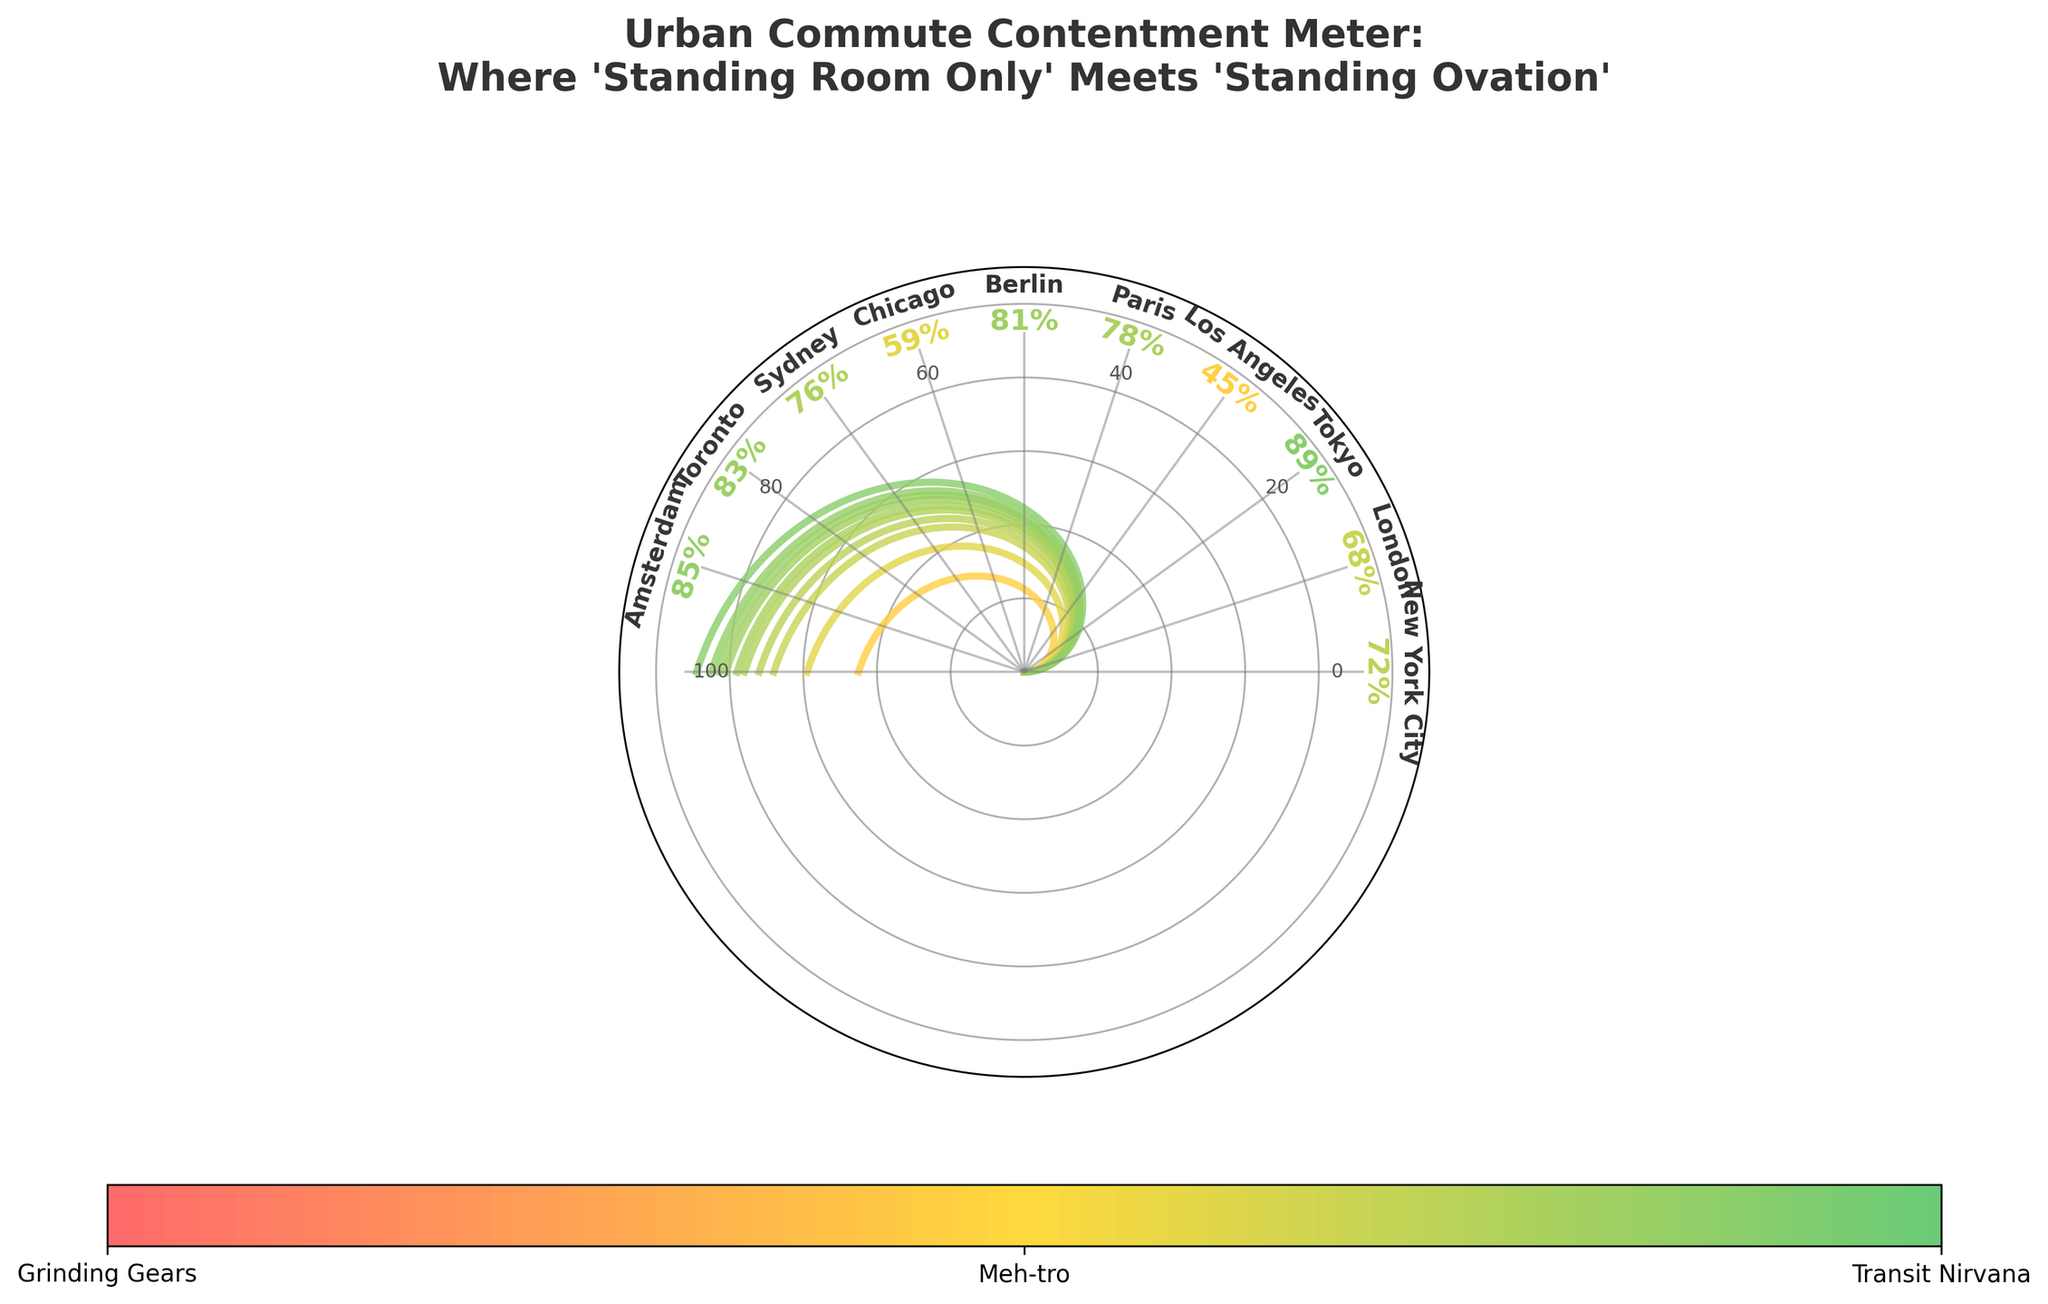Which city has the highest satisfaction level? The city with the highest satisfaction level is the one at the top of the gauge closest to the maximum value of 100%. By referring to the gauge chart, Tokyo has the highest satisfaction level at 89%.
Answer: Tokyo Which two cities have satisfaction levels in the 80s? To answer this, we need to identify the cities shown in the segment of the gauge chart that corresponds to the 80-89% range. Berlin and Toronto both fall into this range, with satisfaction levels of 81% and 83% respectively.
Answer: Berlin and Toronto What is the difference between the highest and lowest satisfaction levels? First, we find the highest satisfaction level, which is Tokyo at 89%, and the lowest satisfaction level, which is Los Angeles at 45%. Subtracting these two values gives us 89% - 45% = 44%.
Answer: 44% Which city has a satisfaction level closest to 75%? Looking at the gauge chart, we see cities plotted around the 75% mark. Sydney, with a satisfaction level of 76%, is closest to this value.
Answer: Sydney Which city has a higher satisfaction level, Paris or Chicago, and by how much? Paris has a satisfaction level of 78%, while Chicago has 59%. Subtracting the two values gives us 78% - 59% = 19%.
Answer: Paris, by 19% How many cities have satisfaction levels higher than 80%? Observing the gauge chart, we see that there are four cities with satisfaction levels above 80%: Tokyo (89%), Berlin (81%), Toronto (83%), and Amsterdam (85%).
Answer: 4 What is the average satisfaction level of all the cities in the chart? To find the average, sum up all the satisfaction levels and divide by the total number of cities. The sum is 72 + 68 + 89 + 45 + 78 + 81 + 59 + 76 + 83 + 85 = 736. Dividing by the number of cities, 10, gives us 736/10 = 73.6%.
Answer: 73.6% Which city's satisfaction level is used to label the segment "Grinding Gears"? The gauge chart's color segments are labeled, and the section labeled "Grinding Gears" is for the lowest satisfaction levels. Los Angeles, with a satisfaction level of 45%, falls into this segment.
Answer: Los Angeles What is the most common satisfaction level range among the cities (0-50%, 51-75%, or 76-100%)? By counting the cities in each range: 0-50% has 1 city (Los Angeles), 51-75% has 4 cities (New York City, London, Chicago, Sydney), and 76-100% has 5 cities (Paris, Berlin, Toronto, Amsterdam, Tokyo). The most common range is 76-100%.
Answer: 76-100% Which city has a satisfaction level closest to the median satisfaction level? First, we need to list the satisfaction levels in order: 45, 59, 68, 72, 76, 78, 81, 83, 85, 89. The median of this list is the average of the 5th and 6th values, which are 76 and 78. The median is (76+78)/2 = 77. The city with a satisfaction level closest to 77 is Paris, with 78%.
Answer: Paris 